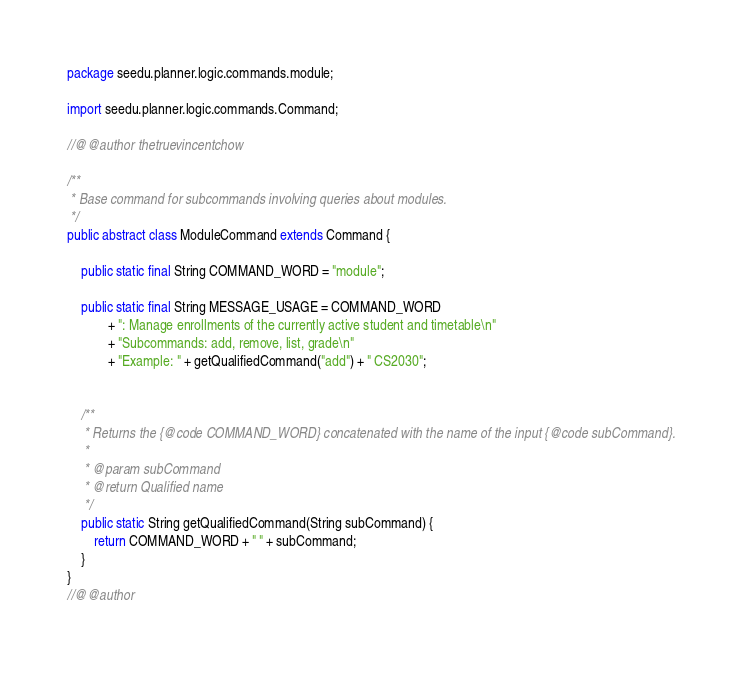<code> <loc_0><loc_0><loc_500><loc_500><_Java_>package seedu.planner.logic.commands.module;

import seedu.planner.logic.commands.Command;

//@@author thetruevincentchow

/**
 * Base command for subcommands involving queries about modules.
 */
public abstract class ModuleCommand extends Command {

    public static final String COMMAND_WORD = "module";

    public static final String MESSAGE_USAGE = COMMAND_WORD
            + ": Manage enrollments of the currently active student and timetable\n"
            + "Subcommands: add, remove, list, grade\n"
            + "Example: " + getQualifiedCommand("add") + " CS2030";


    /**
     * Returns the {@code COMMAND_WORD} concatenated with the name of the input {@code subCommand}.
     *
     * @param subCommand
     * @return Qualified name
     */
    public static String getQualifiedCommand(String subCommand) {
        return COMMAND_WORD + " " + subCommand;
    }
}
//@@author
</code> 